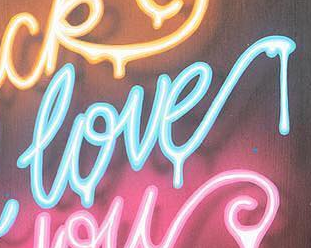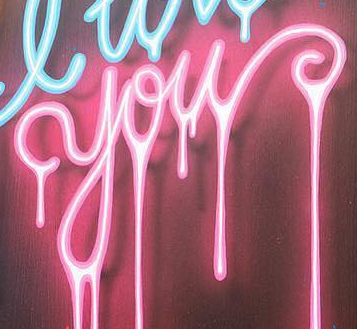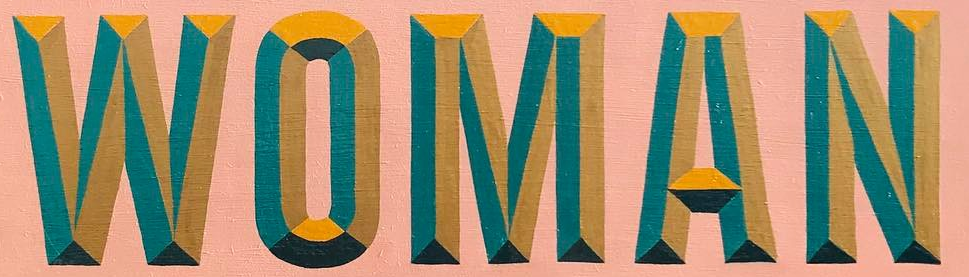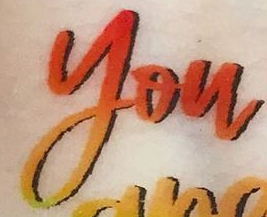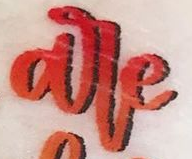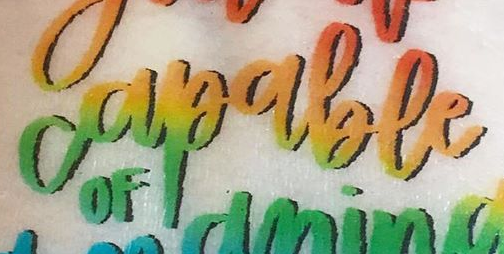What words can you see in these images in sequence, separated by a semicolon? love; you; WOMAN; you; are; capable 